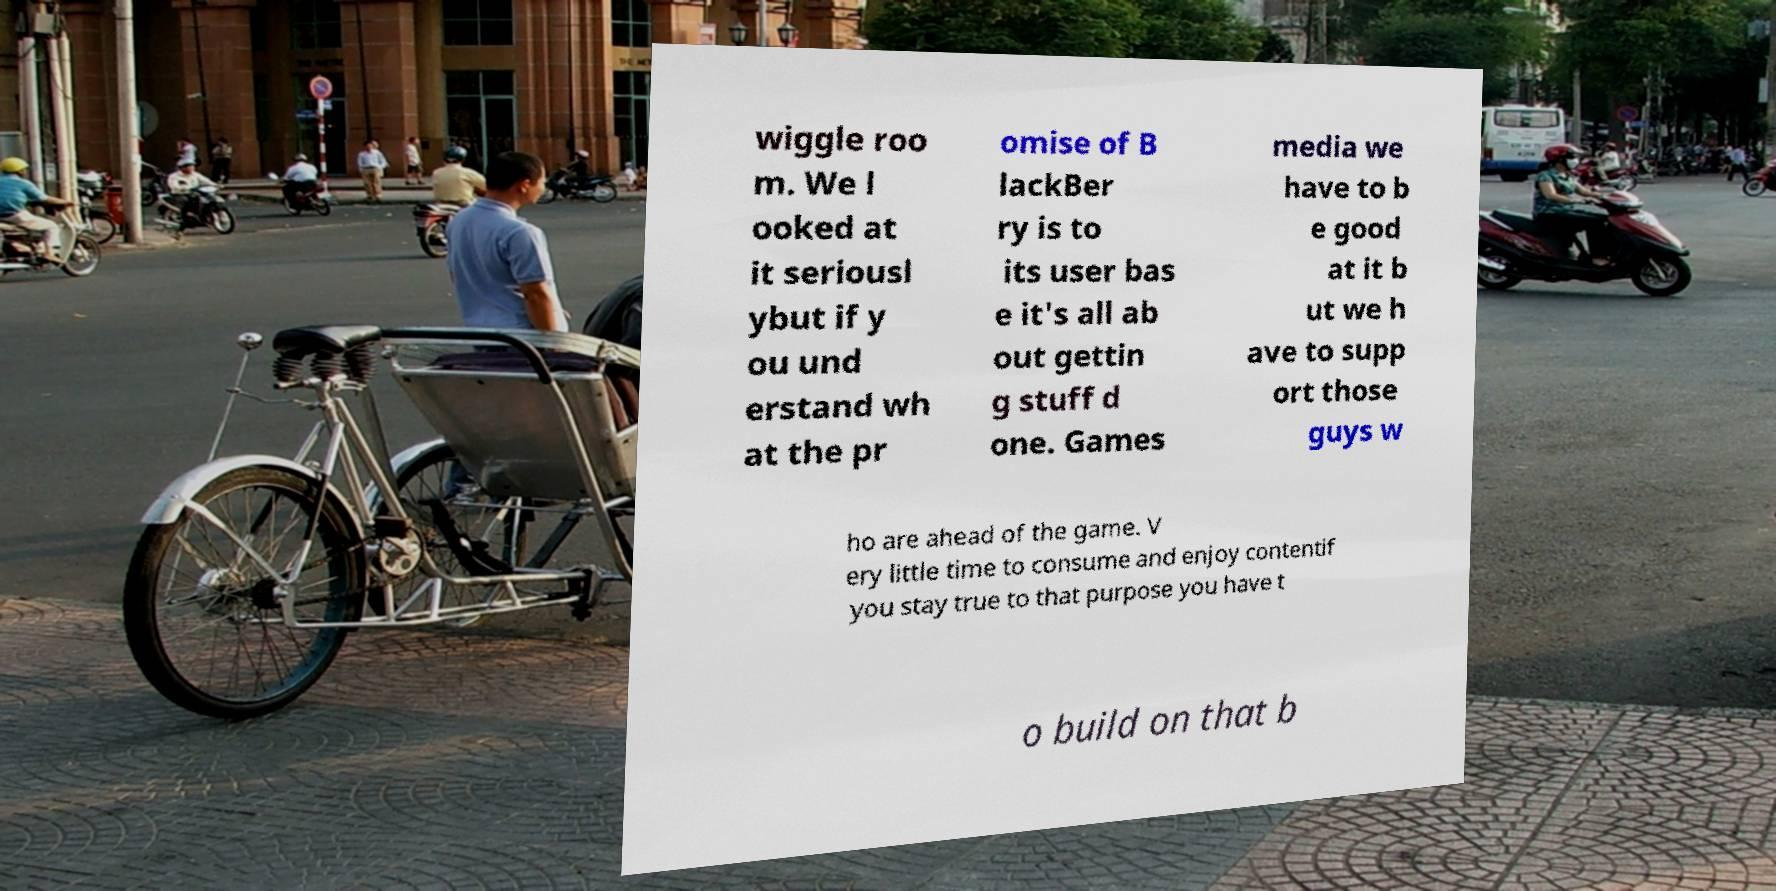There's text embedded in this image that I need extracted. Can you transcribe it verbatim? wiggle roo m. We l ooked at it seriousl ybut if y ou und erstand wh at the pr omise of B lackBer ry is to its user bas e it's all ab out gettin g stuff d one. Games media we have to b e good at it b ut we h ave to supp ort those guys w ho are ahead of the game. V ery little time to consume and enjoy contentif you stay true to that purpose you have t o build on that b 